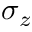Convert formula to latex. <formula><loc_0><loc_0><loc_500><loc_500>\sigma _ { z }</formula> 